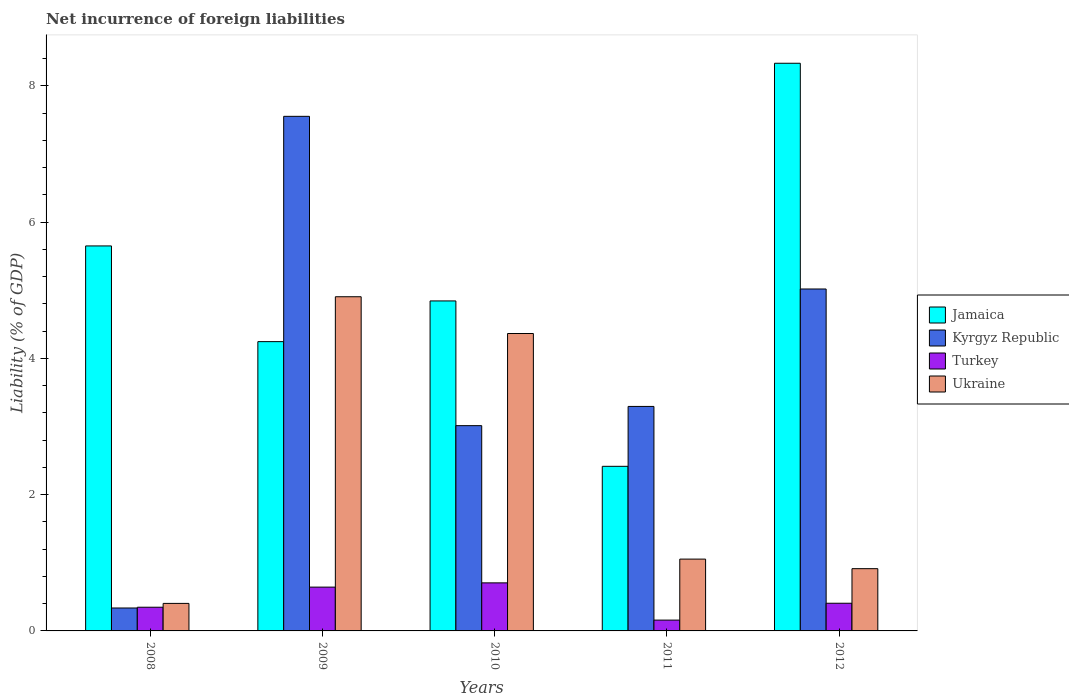How many different coloured bars are there?
Offer a very short reply. 4. Are the number of bars on each tick of the X-axis equal?
Provide a succinct answer. Yes. How many bars are there on the 5th tick from the left?
Provide a short and direct response. 4. What is the label of the 3rd group of bars from the left?
Your answer should be compact. 2010. What is the net incurrence of foreign liabilities in Jamaica in 2008?
Offer a terse response. 5.65. Across all years, what is the maximum net incurrence of foreign liabilities in Turkey?
Give a very brief answer. 0.71. Across all years, what is the minimum net incurrence of foreign liabilities in Kyrgyz Republic?
Ensure brevity in your answer.  0.34. In which year was the net incurrence of foreign liabilities in Turkey maximum?
Make the answer very short. 2010. In which year was the net incurrence of foreign liabilities in Jamaica minimum?
Provide a short and direct response. 2011. What is the total net incurrence of foreign liabilities in Kyrgyz Republic in the graph?
Make the answer very short. 19.22. What is the difference between the net incurrence of foreign liabilities in Kyrgyz Republic in 2008 and that in 2012?
Ensure brevity in your answer.  -4.68. What is the difference between the net incurrence of foreign liabilities in Ukraine in 2009 and the net incurrence of foreign liabilities in Kyrgyz Republic in 2012?
Offer a terse response. -0.11. What is the average net incurrence of foreign liabilities in Ukraine per year?
Give a very brief answer. 2.33. In the year 2008, what is the difference between the net incurrence of foreign liabilities in Jamaica and net incurrence of foreign liabilities in Turkey?
Offer a very short reply. 5.3. What is the ratio of the net incurrence of foreign liabilities in Kyrgyz Republic in 2009 to that in 2012?
Provide a succinct answer. 1.5. Is the net incurrence of foreign liabilities in Turkey in 2009 less than that in 2011?
Your answer should be compact. No. Is the difference between the net incurrence of foreign liabilities in Jamaica in 2009 and 2012 greater than the difference between the net incurrence of foreign liabilities in Turkey in 2009 and 2012?
Provide a succinct answer. No. What is the difference between the highest and the second highest net incurrence of foreign liabilities in Turkey?
Keep it short and to the point. 0.06. What is the difference between the highest and the lowest net incurrence of foreign liabilities in Turkey?
Your answer should be compact. 0.55. In how many years, is the net incurrence of foreign liabilities in Kyrgyz Republic greater than the average net incurrence of foreign liabilities in Kyrgyz Republic taken over all years?
Your response must be concise. 2. Is the sum of the net incurrence of foreign liabilities in Ukraine in 2009 and 2012 greater than the maximum net incurrence of foreign liabilities in Jamaica across all years?
Keep it short and to the point. No. Is it the case that in every year, the sum of the net incurrence of foreign liabilities in Jamaica and net incurrence of foreign liabilities in Ukraine is greater than the sum of net incurrence of foreign liabilities in Kyrgyz Republic and net incurrence of foreign liabilities in Turkey?
Offer a very short reply. Yes. What does the 3rd bar from the left in 2009 represents?
Ensure brevity in your answer.  Turkey. What does the 3rd bar from the right in 2008 represents?
Offer a terse response. Kyrgyz Republic. How many bars are there?
Make the answer very short. 20. Are all the bars in the graph horizontal?
Your answer should be compact. No. How many years are there in the graph?
Ensure brevity in your answer.  5. What is the difference between two consecutive major ticks on the Y-axis?
Offer a terse response. 2. Are the values on the major ticks of Y-axis written in scientific E-notation?
Offer a terse response. No. How many legend labels are there?
Provide a succinct answer. 4. What is the title of the graph?
Your answer should be compact. Net incurrence of foreign liabilities. Does "Mauritania" appear as one of the legend labels in the graph?
Provide a succinct answer. No. What is the label or title of the X-axis?
Offer a very short reply. Years. What is the label or title of the Y-axis?
Your answer should be very brief. Liability (% of GDP). What is the Liability (% of GDP) in Jamaica in 2008?
Offer a terse response. 5.65. What is the Liability (% of GDP) in Kyrgyz Republic in 2008?
Provide a succinct answer. 0.34. What is the Liability (% of GDP) in Turkey in 2008?
Keep it short and to the point. 0.35. What is the Liability (% of GDP) of Ukraine in 2008?
Make the answer very short. 0.4. What is the Liability (% of GDP) of Jamaica in 2009?
Make the answer very short. 4.25. What is the Liability (% of GDP) in Kyrgyz Republic in 2009?
Offer a terse response. 7.55. What is the Liability (% of GDP) in Turkey in 2009?
Your answer should be very brief. 0.64. What is the Liability (% of GDP) of Ukraine in 2009?
Provide a succinct answer. 4.91. What is the Liability (% of GDP) in Jamaica in 2010?
Keep it short and to the point. 4.84. What is the Liability (% of GDP) in Kyrgyz Republic in 2010?
Your answer should be very brief. 3.01. What is the Liability (% of GDP) in Turkey in 2010?
Give a very brief answer. 0.71. What is the Liability (% of GDP) of Ukraine in 2010?
Make the answer very short. 4.37. What is the Liability (% of GDP) in Jamaica in 2011?
Provide a short and direct response. 2.42. What is the Liability (% of GDP) in Kyrgyz Republic in 2011?
Your answer should be very brief. 3.3. What is the Liability (% of GDP) in Turkey in 2011?
Your response must be concise. 0.16. What is the Liability (% of GDP) of Ukraine in 2011?
Your response must be concise. 1.05. What is the Liability (% of GDP) of Jamaica in 2012?
Give a very brief answer. 8.33. What is the Liability (% of GDP) of Kyrgyz Republic in 2012?
Ensure brevity in your answer.  5.02. What is the Liability (% of GDP) in Turkey in 2012?
Offer a terse response. 0.41. What is the Liability (% of GDP) of Ukraine in 2012?
Offer a very short reply. 0.91. Across all years, what is the maximum Liability (% of GDP) of Jamaica?
Provide a succinct answer. 8.33. Across all years, what is the maximum Liability (% of GDP) in Kyrgyz Republic?
Make the answer very short. 7.55. Across all years, what is the maximum Liability (% of GDP) of Turkey?
Give a very brief answer. 0.71. Across all years, what is the maximum Liability (% of GDP) of Ukraine?
Give a very brief answer. 4.91. Across all years, what is the minimum Liability (% of GDP) of Jamaica?
Offer a terse response. 2.42. Across all years, what is the minimum Liability (% of GDP) of Kyrgyz Republic?
Ensure brevity in your answer.  0.34. Across all years, what is the minimum Liability (% of GDP) in Turkey?
Ensure brevity in your answer.  0.16. Across all years, what is the minimum Liability (% of GDP) in Ukraine?
Offer a terse response. 0.4. What is the total Liability (% of GDP) of Jamaica in the graph?
Provide a succinct answer. 25.49. What is the total Liability (% of GDP) of Kyrgyz Republic in the graph?
Your answer should be compact. 19.22. What is the total Liability (% of GDP) of Turkey in the graph?
Your answer should be compact. 2.26. What is the total Liability (% of GDP) in Ukraine in the graph?
Provide a succinct answer. 11.64. What is the difference between the Liability (% of GDP) of Jamaica in 2008 and that in 2009?
Your answer should be very brief. 1.4. What is the difference between the Liability (% of GDP) in Kyrgyz Republic in 2008 and that in 2009?
Give a very brief answer. -7.22. What is the difference between the Liability (% of GDP) of Turkey in 2008 and that in 2009?
Offer a terse response. -0.3. What is the difference between the Liability (% of GDP) in Ukraine in 2008 and that in 2009?
Provide a succinct answer. -4.5. What is the difference between the Liability (% of GDP) in Jamaica in 2008 and that in 2010?
Your answer should be very brief. 0.81. What is the difference between the Liability (% of GDP) of Kyrgyz Republic in 2008 and that in 2010?
Your answer should be very brief. -2.68. What is the difference between the Liability (% of GDP) in Turkey in 2008 and that in 2010?
Provide a succinct answer. -0.36. What is the difference between the Liability (% of GDP) in Ukraine in 2008 and that in 2010?
Offer a very short reply. -3.96. What is the difference between the Liability (% of GDP) of Jamaica in 2008 and that in 2011?
Give a very brief answer. 3.23. What is the difference between the Liability (% of GDP) in Kyrgyz Republic in 2008 and that in 2011?
Provide a short and direct response. -2.96. What is the difference between the Liability (% of GDP) of Turkey in 2008 and that in 2011?
Provide a short and direct response. 0.19. What is the difference between the Liability (% of GDP) in Ukraine in 2008 and that in 2011?
Offer a terse response. -0.65. What is the difference between the Liability (% of GDP) of Jamaica in 2008 and that in 2012?
Your answer should be very brief. -2.68. What is the difference between the Liability (% of GDP) in Kyrgyz Republic in 2008 and that in 2012?
Make the answer very short. -4.68. What is the difference between the Liability (% of GDP) of Turkey in 2008 and that in 2012?
Make the answer very short. -0.06. What is the difference between the Liability (% of GDP) of Ukraine in 2008 and that in 2012?
Your answer should be very brief. -0.51. What is the difference between the Liability (% of GDP) in Jamaica in 2009 and that in 2010?
Your answer should be very brief. -0.6. What is the difference between the Liability (% of GDP) in Kyrgyz Republic in 2009 and that in 2010?
Ensure brevity in your answer.  4.54. What is the difference between the Liability (% of GDP) in Turkey in 2009 and that in 2010?
Offer a terse response. -0.06. What is the difference between the Liability (% of GDP) in Ukraine in 2009 and that in 2010?
Your response must be concise. 0.54. What is the difference between the Liability (% of GDP) in Jamaica in 2009 and that in 2011?
Provide a succinct answer. 1.83. What is the difference between the Liability (% of GDP) in Kyrgyz Republic in 2009 and that in 2011?
Your response must be concise. 4.26. What is the difference between the Liability (% of GDP) of Turkey in 2009 and that in 2011?
Provide a succinct answer. 0.48. What is the difference between the Liability (% of GDP) of Ukraine in 2009 and that in 2011?
Give a very brief answer. 3.85. What is the difference between the Liability (% of GDP) of Jamaica in 2009 and that in 2012?
Offer a very short reply. -4.09. What is the difference between the Liability (% of GDP) of Kyrgyz Republic in 2009 and that in 2012?
Ensure brevity in your answer.  2.53. What is the difference between the Liability (% of GDP) in Turkey in 2009 and that in 2012?
Offer a terse response. 0.24. What is the difference between the Liability (% of GDP) in Ukraine in 2009 and that in 2012?
Ensure brevity in your answer.  3.99. What is the difference between the Liability (% of GDP) in Jamaica in 2010 and that in 2011?
Ensure brevity in your answer.  2.43. What is the difference between the Liability (% of GDP) in Kyrgyz Republic in 2010 and that in 2011?
Your answer should be compact. -0.28. What is the difference between the Liability (% of GDP) of Turkey in 2010 and that in 2011?
Provide a short and direct response. 0.55. What is the difference between the Liability (% of GDP) of Ukraine in 2010 and that in 2011?
Provide a short and direct response. 3.31. What is the difference between the Liability (% of GDP) of Jamaica in 2010 and that in 2012?
Your answer should be very brief. -3.49. What is the difference between the Liability (% of GDP) in Kyrgyz Republic in 2010 and that in 2012?
Give a very brief answer. -2.01. What is the difference between the Liability (% of GDP) of Turkey in 2010 and that in 2012?
Offer a very short reply. 0.3. What is the difference between the Liability (% of GDP) of Ukraine in 2010 and that in 2012?
Your response must be concise. 3.45. What is the difference between the Liability (% of GDP) of Jamaica in 2011 and that in 2012?
Your answer should be compact. -5.92. What is the difference between the Liability (% of GDP) in Kyrgyz Republic in 2011 and that in 2012?
Keep it short and to the point. -1.72. What is the difference between the Liability (% of GDP) in Turkey in 2011 and that in 2012?
Your answer should be very brief. -0.25. What is the difference between the Liability (% of GDP) in Ukraine in 2011 and that in 2012?
Provide a short and direct response. 0.14. What is the difference between the Liability (% of GDP) of Jamaica in 2008 and the Liability (% of GDP) of Kyrgyz Republic in 2009?
Provide a short and direct response. -1.9. What is the difference between the Liability (% of GDP) in Jamaica in 2008 and the Liability (% of GDP) in Turkey in 2009?
Offer a very short reply. 5.01. What is the difference between the Liability (% of GDP) in Jamaica in 2008 and the Liability (% of GDP) in Ukraine in 2009?
Ensure brevity in your answer.  0.75. What is the difference between the Liability (% of GDP) of Kyrgyz Republic in 2008 and the Liability (% of GDP) of Turkey in 2009?
Offer a very short reply. -0.31. What is the difference between the Liability (% of GDP) in Kyrgyz Republic in 2008 and the Liability (% of GDP) in Ukraine in 2009?
Keep it short and to the point. -4.57. What is the difference between the Liability (% of GDP) in Turkey in 2008 and the Liability (% of GDP) in Ukraine in 2009?
Offer a terse response. -4.56. What is the difference between the Liability (% of GDP) of Jamaica in 2008 and the Liability (% of GDP) of Kyrgyz Republic in 2010?
Provide a succinct answer. 2.64. What is the difference between the Liability (% of GDP) of Jamaica in 2008 and the Liability (% of GDP) of Turkey in 2010?
Keep it short and to the point. 4.95. What is the difference between the Liability (% of GDP) in Jamaica in 2008 and the Liability (% of GDP) in Ukraine in 2010?
Offer a very short reply. 1.29. What is the difference between the Liability (% of GDP) of Kyrgyz Republic in 2008 and the Liability (% of GDP) of Turkey in 2010?
Offer a terse response. -0.37. What is the difference between the Liability (% of GDP) of Kyrgyz Republic in 2008 and the Liability (% of GDP) of Ukraine in 2010?
Your answer should be compact. -4.03. What is the difference between the Liability (% of GDP) in Turkey in 2008 and the Liability (% of GDP) in Ukraine in 2010?
Your answer should be very brief. -4.02. What is the difference between the Liability (% of GDP) of Jamaica in 2008 and the Liability (% of GDP) of Kyrgyz Republic in 2011?
Provide a short and direct response. 2.36. What is the difference between the Liability (% of GDP) in Jamaica in 2008 and the Liability (% of GDP) in Turkey in 2011?
Provide a short and direct response. 5.49. What is the difference between the Liability (% of GDP) of Jamaica in 2008 and the Liability (% of GDP) of Ukraine in 2011?
Give a very brief answer. 4.6. What is the difference between the Liability (% of GDP) of Kyrgyz Republic in 2008 and the Liability (% of GDP) of Turkey in 2011?
Your answer should be very brief. 0.18. What is the difference between the Liability (% of GDP) in Kyrgyz Republic in 2008 and the Liability (% of GDP) in Ukraine in 2011?
Ensure brevity in your answer.  -0.72. What is the difference between the Liability (% of GDP) of Turkey in 2008 and the Liability (% of GDP) of Ukraine in 2011?
Offer a terse response. -0.71. What is the difference between the Liability (% of GDP) in Jamaica in 2008 and the Liability (% of GDP) in Kyrgyz Republic in 2012?
Your response must be concise. 0.63. What is the difference between the Liability (% of GDP) of Jamaica in 2008 and the Liability (% of GDP) of Turkey in 2012?
Provide a succinct answer. 5.24. What is the difference between the Liability (% of GDP) in Jamaica in 2008 and the Liability (% of GDP) in Ukraine in 2012?
Keep it short and to the point. 4.74. What is the difference between the Liability (% of GDP) in Kyrgyz Republic in 2008 and the Liability (% of GDP) in Turkey in 2012?
Make the answer very short. -0.07. What is the difference between the Liability (% of GDP) of Kyrgyz Republic in 2008 and the Liability (% of GDP) of Ukraine in 2012?
Provide a short and direct response. -0.58. What is the difference between the Liability (% of GDP) of Turkey in 2008 and the Liability (% of GDP) of Ukraine in 2012?
Your answer should be compact. -0.57. What is the difference between the Liability (% of GDP) in Jamaica in 2009 and the Liability (% of GDP) in Kyrgyz Republic in 2010?
Provide a succinct answer. 1.23. What is the difference between the Liability (% of GDP) in Jamaica in 2009 and the Liability (% of GDP) in Turkey in 2010?
Your response must be concise. 3.54. What is the difference between the Liability (% of GDP) in Jamaica in 2009 and the Liability (% of GDP) in Ukraine in 2010?
Your response must be concise. -0.12. What is the difference between the Liability (% of GDP) in Kyrgyz Republic in 2009 and the Liability (% of GDP) in Turkey in 2010?
Give a very brief answer. 6.85. What is the difference between the Liability (% of GDP) of Kyrgyz Republic in 2009 and the Liability (% of GDP) of Ukraine in 2010?
Your response must be concise. 3.19. What is the difference between the Liability (% of GDP) of Turkey in 2009 and the Liability (% of GDP) of Ukraine in 2010?
Give a very brief answer. -3.72. What is the difference between the Liability (% of GDP) in Jamaica in 2009 and the Liability (% of GDP) in Kyrgyz Republic in 2011?
Provide a short and direct response. 0.95. What is the difference between the Liability (% of GDP) in Jamaica in 2009 and the Liability (% of GDP) in Turkey in 2011?
Keep it short and to the point. 4.09. What is the difference between the Liability (% of GDP) in Jamaica in 2009 and the Liability (% of GDP) in Ukraine in 2011?
Give a very brief answer. 3.19. What is the difference between the Liability (% of GDP) of Kyrgyz Republic in 2009 and the Liability (% of GDP) of Turkey in 2011?
Make the answer very short. 7.39. What is the difference between the Liability (% of GDP) of Kyrgyz Republic in 2009 and the Liability (% of GDP) of Ukraine in 2011?
Your answer should be very brief. 6.5. What is the difference between the Liability (% of GDP) in Turkey in 2009 and the Liability (% of GDP) in Ukraine in 2011?
Ensure brevity in your answer.  -0.41. What is the difference between the Liability (% of GDP) of Jamaica in 2009 and the Liability (% of GDP) of Kyrgyz Republic in 2012?
Your answer should be compact. -0.77. What is the difference between the Liability (% of GDP) in Jamaica in 2009 and the Liability (% of GDP) in Turkey in 2012?
Make the answer very short. 3.84. What is the difference between the Liability (% of GDP) in Jamaica in 2009 and the Liability (% of GDP) in Ukraine in 2012?
Provide a succinct answer. 3.33. What is the difference between the Liability (% of GDP) of Kyrgyz Republic in 2009 and the Liability (% of GDP) of Turkey in 2012?
Give a very brief answer. 7.15. What is the difference between the Liability (% of GDP) of Kyrgyz Republic in 2009 and the Liability (% of GDP) of Ukraine in 2012?
Provide a succinct answer. 6.64. What is the difference between the Liability (% of GDP) in Turkey in 2009 and the Liability (% of GDP) in Ukraine in 2012?
Give a very brief answer. -0.27. What is the difference between the Liability (% of GDP) of Jamaica in 2010 and the Liability (% of GDP) of Kyrgyz Republic in 2011?
Offer a very short reply. 1.55. What is the difference between the Liability (% of GDP) in Jamaica in 2010 and the Liability (% of GDP) in Turkey in 2011?
Keep it short and to the point. 4.68. What is the difference between the Liability (% of GDP) of Jamaica in 2010 and the Liability (% of GDP) of Ukraine in 2011?
Your response must be concise. 3.79. What is the difference between the Liability (% of GDP) of Kyrgyz Republic in 2010 and the Liability (% of GDP) of Turkey in 2011?
Offer a terse response. 2.85. What is the difference between the Liability (% of GDP) of Kyrgyz Republic in 2010 and the Liability (% of GDP) of Ukraine in 2011?
Offer a terse response. 1.96. What is the difference between the Liability (% of GDP) of Turkey in 2010 and the Liability (% of GDP) of Ukraine in 2011?
Your answer should be compact. -0.35. What is the difference between the Liability (% of GDP) of Jamaica in 2010 and the Liability (% of GDP) of Kyrgyz Republic in 2012?
Ensure brevity in your answer.  -0.18. What is the difference between the Liability (% of GDP) in Jamaica in 2010 and the Liability (% of GDP) in Turkey in 2012?
Keep it short and to the point. 4.44. What is the difference between the Liability (% of GDP) of Jamaica in 2010 and the Liability (% of GDP) of Ukraine in 2012?
Your answer should be very brief. 3.93. What is the difference between the Liability (% of GDP) in Kyrgyz Republic in 2010 and the Liability (% of GDP) in Turkey in 2012?
Your answer should be very brief. 2.61. What is the difference between the Liability (% of GDP) of Kyrgyz Republic in 2010 and the Liability (% of GDP) of Ukraine in 2012?
Make the answer very short. 2.1. What is the difference between the Liability (% of GDP) of Turkey in 2010 and the Liability (% of GDP) of Ukraine in 2012?
Your response must be concise. -0.21. What is the difference between the Liability (% of GDP) of Jamaica in 2011 and the Liability (% of GDP) of Kyrgyz Republic in 2012?
Make the answer very short. -2.6. What is the difference between the Liability (% of GDP) of Jamaica in 2011 and the Liability (% of GDP) of Turkey in 2012?
Ensure brevity in your answer.  2.01. What is the difference between the Liability (% of GDP) of Jamaica in 2011 and the Liability (% of GDP) of Ukraine in 2012?
Provide a short and direct response. 1.5. What is the difference between the Liability (% of GDP) of Kyrgyz Republic in 2011 and the Liability (% of GDP) of Turkey in 2012?
Keep it short and to the point. 2.89. What is the difference between the Liability (% of GDP) of Kyrgyz Republic in 2011 and the Liability (% of GDP) of Ukraine in 2012?
Provide a succinct answer. 2.38. What is the difference between the Liability (% of GDP) of Turkey in 2011 and the Liability (% of GDP) of Ukraine in 2012?
Ensure brevity in your answer.  -0.76. What is the average Liability (% of GDP) in Jamaica per year?
Ensure brevity in your answer.  5.1. What is the average Liability (% of GDP) in Kyrgyz Republic per year?
Your answer should be compact. 3.84. What is the average Liability (% of GDP) of Turkey per year?
Offer a terse response. 0.45. What is the average Liability (% of GDP) of Ukraine per year?
Give a very brief answer. 2.33. In the year 2008, what is the difference between the Liability (% of GDP) in Jamaica and Liability (% of GDP) in Kyrgyz Republic?
Ensure brevity in your answer.  5.31. In the year 2008, what is the difference between the Liability (% of GDP) of Jamaica and Liability (% of GDP) of Turkey?
Make the answer very short. 5.3. In the year 2008, what is the difference between the Liability (% of GDP) of Jamaica and Liability (% of GDP) of Ukraine?
Provide a short and direct response. 5.25. In the year 2008, what is the difference between the Liability (% of GDP) of Kyrgyz Republic and Liability (% of GDP) of Turkey?
Provide a short and direct response. -0.01. In the year 2008, what is the difference between the Liability (% of GDP) of Kyrgyz Republic and Liability (% of GDP) of Ukraine?
Make the answer very short. -0.07. In the year 2008, what is the difference between the Liability (% of GDP) in Turkey and Liability (% of GDP) in Ukraine?
Provide a succinct answer. -0.06. In the year 2009, what is the difference between the Liability (% of GDP) of Jamaica and Liability (% of GDP) of Kyrgyz Republic?
Make the answer very short. -3.31. In the year 2009, what is the difference between the Liability (% of GDP) in Jamaica and Liability (% of GDP) in Turkey?
Give a very brief answer. 3.6. In the year 2009, what is the difference between the Liability (% of GDP) of Jamaica and Liability (% of GDP) of Ukraine?
Ensure brevity in your answer.  -0.66. In the year 2009, what is the difference between the Liability (% of GDP) of Kyrgyz Republic and Liability (% of GDP) of Turkey?
Keep it short and to the point. 6.91. In the year 2009, what is the difference between the Liability (% of GDP) in Kyrgyz Republic and Liability (% of GDP) in Ukraine?
Offer a very short reply. 2.65. In the year 2009, what is the difference between the Liability (% of GDP) in Turkey and Liability (% of GDP) in Ukraine?
Your answer should be compact. -4.26. In the year 2010, what is the difference between the Liability (% of GDP) of Jamaica and Liability (% of GDP) of Kyrgyz Republic?
Provide a short and direct response. 1.83. In the year 2010, what is the difference between the Liability (% of GDP) in Jamaica and Liability (% of GDP) in Turkey?
Your answer should be compact. 4.14. In the year 2010, what is the difference between the Liability (% of GDP) of Jamaica and Liability (% of GDP) of Ukraine?
Your answer should be compact. 0.48. In the year 2010, what is the difference between the Liability (% of GDP) in Kyrgyz Republic and Liability (% of GDP) in Turkey?
Your response must be concise. 2.31. In the year 2010, what is the difference between the Liability (% of GDP) of Kyrgyz Republic and Liability (% of GDP) of Ukraine?
Provide a succinct answer. -1.35. In the year 2010, what is the difference between the Liability (% of GDP) of Turkey and Liability (% of GDP) of Ukraine?
Your response must be concise. -3.66. In the year 2011, what is the difference between the Liability (% of GDP) in Jamaica and Liability (% of GDP) in Kyrgyz Republic?
Offer a terse response. -0.88. In the year 2011, what is the difference between the Liability (% of GDP) in Jamaica and Liability (% of GDP) in Turkey?
Give a very brief answer. 2.26. In the year 2011, what is the difference between the Liability (% of GDP) in Jamaica and Liability (% of GDP) in Ukraine?
Your response must be concise. 1.36. In the year 2011, what is the difference between the Liability (% of GDP) of Kyrgyz Republic and Liability (% of GDP) of Turkey?
Give a very brief answer. 3.14. In the year 2011, what is the difference between the Liability (% of GDP) of Kyrgyz Republic and Liability (% of GDP) of Ukraine?
Your answer should be compact. 2.24. In the year 2011, what is the difference between the Liability (% of GDP) in Turkey and Liability (% of GDP) in Ukraine?
Provide a succinct answer. -0.9. In the year 2012, what is the difference between the Liability (% of GDP) in Jamaica and Liability (% of GDP) in Kyrgyz Republic?
Offer a terse response. 3.31. In the year 2012, what is the difference between the Liability (% of GDP) in Jamaica and Liability (% of GDP) in Turkey?
Provide a succinct answer. 7.93. In the year 2012, what is the difference between the Liability (% of GDP) in Jamaica and Liability (% of GDP) in Ukraine?
Offer a very short reply. 7.42. In the year 2012, what is the difference between the Liability (% of GDP) in Kyrgyz Republic and Liability (% of GDP) in Turkey?
Make the answer very short. 4.61. In the year 2012, what is the difference between the Liability (% of GDP) of Kyrgyz Republic and Liability (% of GDP) of Ukraine?
Provide a succinct answer. 4.11. In the year 2012, what is the difference between the Liability (% of GDP) of Turkey and Liability (% of GDP) of Ukraine?
Make the answer very short. -0.51. What is the ratio of the Liability (% of GDP) in Jamaica in 2008 to that in 2009?
Ensure brevity in your answer.  1.33. What is the ratio of the Liability (% of GDP) in Kyrgyz Republic in 2008 to that in 2009?
Keep it short and to the point. 0.04. What is the ratio of the Liability (% of GDP) of Turkey in 2008 to that in 2009?
Ensure brevity in your answer.  0.54. What is the ratio of the Liability (% of GDP) in Ukraine in 2008 to that in 2009?
Make the answer very short. 0.08. What is the ratio of the Liability (% of GDP) of Jamaica in 2008 to that in 2010?
Provide a short and direct response. 1.17. What is the ratio of the Liability (% of GDP) of Kyrgyz Republic in 2008 to that in 2010?
Keep it short and to the point. 0.11. What is the ratio of the Liability (% of GDP) in Turkey in 2008 to that in 2010?
Your response must be concise. 0.49. What is the ratio of the Liability (% of GDP) of Ukraine in 2008 to that in 2010?
Your answer should be compact. 0.09. What is the ratio of the Liability (% of GDP) in Jamaica in 2008 to that in 2011?
Offer a very short reply. 2.34. What is the ratio of the Liability (% of GDP) in Kyrgyz Republic in 2008 to that in 2011?
Offer a terse response. 0.1. What is the ratio of the Liability (% of GDP) of Turkey in 2008 to that in 2011?
Ensure brevity in your answer.  2.19. What is the ratio of the Liability (% of GDP) in Ukraine in 2008 to that in 2011?
Keep it short and to the point. 0.38. What is the ratio of the Liability (% of GDP) in Jamaica in 2008 to that in 2012?
Make the answer very short. 0.68. What is the ratio of the Liability (% of GDP) of Kyrgyz Republic in 2008 to that in 2012?
Give a very brief answer. 0.07. What is the ratio of the Liability (% of GDP) of Turkey in 2008 to that in 2012?
Offer a very short reply. 0.86. What is the ratio of the Liability (% of GDP) of Ukraine in 2008 to that in 2012?
Your response must be concise. 0.44. What is the ratio of the Liability (% of GDP) in Jamaica in 2009 to that in 2010?
Make the answer very short. 0.88. What is the ratio of the Liability (% of GDP) of Kyrgyz Republic in 2009 to that in 2010?
Provide a short and direct response. 2.51. What is the ratio of the Liability (% of GDP) of Turkey in 2009 to that in 2010?
Your answer should be very brief. 0.91. What is the ratio of the Liability (% of GDP) in Ukraine in 2009 to that in 2010?
Your answer should be compact. 1.12. What is the ratio of the Liability (% of GDP) in Jamaica in 2009 to that in 2011?
Provide a short and direct response. 1.76. What is the ratio of the Liability (% of GDP) of Kyrgyz Republic in 2009 to that in 2011?
Your response must be concise. 2.29. What is the ratio of the Liability (% of GDP) of Turkey in 2009 to that in 2011?
Offer a terse response. 4.05. What is the ratio of the Liability (% of GDP) in Ukraine in 2009 to that in 2011?
Give a very brief answer. 4.65. What is the ratio of the Liability (% of GDP) of Jamaica in 2009 to that in 2012?
Make the answer very short. 0.51. What is the ratio of the Liability (% of GDP) in Kyrgyz Republic in 2009 to that in 2012?
Ensure brevity in your answer.  1.5. What is the ratio of the Liability (% of GDP) of Turkey in 2009 to that in 2012?
Make the answer very short. 1.58. What is the ratio of the Liability (% of GDP) of Ukraine in 2009 to that in 2012?
Your response must be concise. 5.37. What is the ratio of the Liability (% of GDP) of Jamaica in 2010 to that in 2011?
Provide a succinct answer. 2. What is the ratio of the Liability (% of GDP) of Kyrgyz Republic in 2010 to that in 2011?
Your answer should be very brief. 0.91. What is the ratio of the Liability (% of GDP) of Turkey in 2010 to that in 2011?
Keep it short and to the point. 4.44. What is the ratio of the Liability (% of GDP) in Ukraine in 2010 to that in 2011?
Provide a short and direct response. 4.14. What is the ratio of the Liability (% of GDP) in Jamaica in 2010 to that in 2012?
Give a very brief answer. 0.58. What is the ratio of the Liability (% of GDP) in Kyrgyz Republic in 2010 to that in 2012?
Give a very brief answer. 0.6. What is the ratio of the Liability (% of GDP) in Turkey in 2010 to that in 2012?
Give a very brief answer. 1.74. What is the ratio of the Liability (% of GDP) of Ukraine in 2010 to that in 2012?
Offer a very short reply. 4.78. What is the ratio of the Liability (% of GDP) of Jamaica in 2011 to that in 2012?
Provide a succinct answer. 0.29. What is the ratio of the Liability (% of GDP) in Kyrgyz Republic in 2011 to that in 2012?
Your answer should be compact. 0.66. What is the ratio of the Liability (% of GDP) in Turkey in 2011 to that in 2012?
Your answer should be compact. 0.39. What is the ratio of the Liability (% of GDP) of Ukraine in 2011 to that in 2012?
Your response must be concise. 1.15. What is the difference between the highest and the second highest Liability (% of GDP) of Jamaica?
Your answer should be very brief. 2.68. What is the difference between the highest and the second highest Liability (% of GDP) of Kyrgyz Republic?
Your response must be concise. 2.53. What is the difference between the highest and the second highest Liability (% of GDP) of Turkey?
Ensure brevity in your answer.  0.06. What is the difference between the highest and the second highest Liability (% of GDP) in Ukraine?
Your answer should be compact. 0.54. What is the difference between the highest and the lowest Liability (% of GDP) in Jamaica?
Your response must be concise. 5.92. What is the difference between the highest and the lowest Liability (% of GDP) in Kyrgyz Republic?
Keep it short and to the point. 7.22. What is the difference between the highest and the lowest Liability (% of GDP) of Turkey?
Your answer should be compact. 0.55. What is the difference between the highest and the lowest Liability (% of GDP) of Ukraine?
Your answer should be compact. 4.5. 